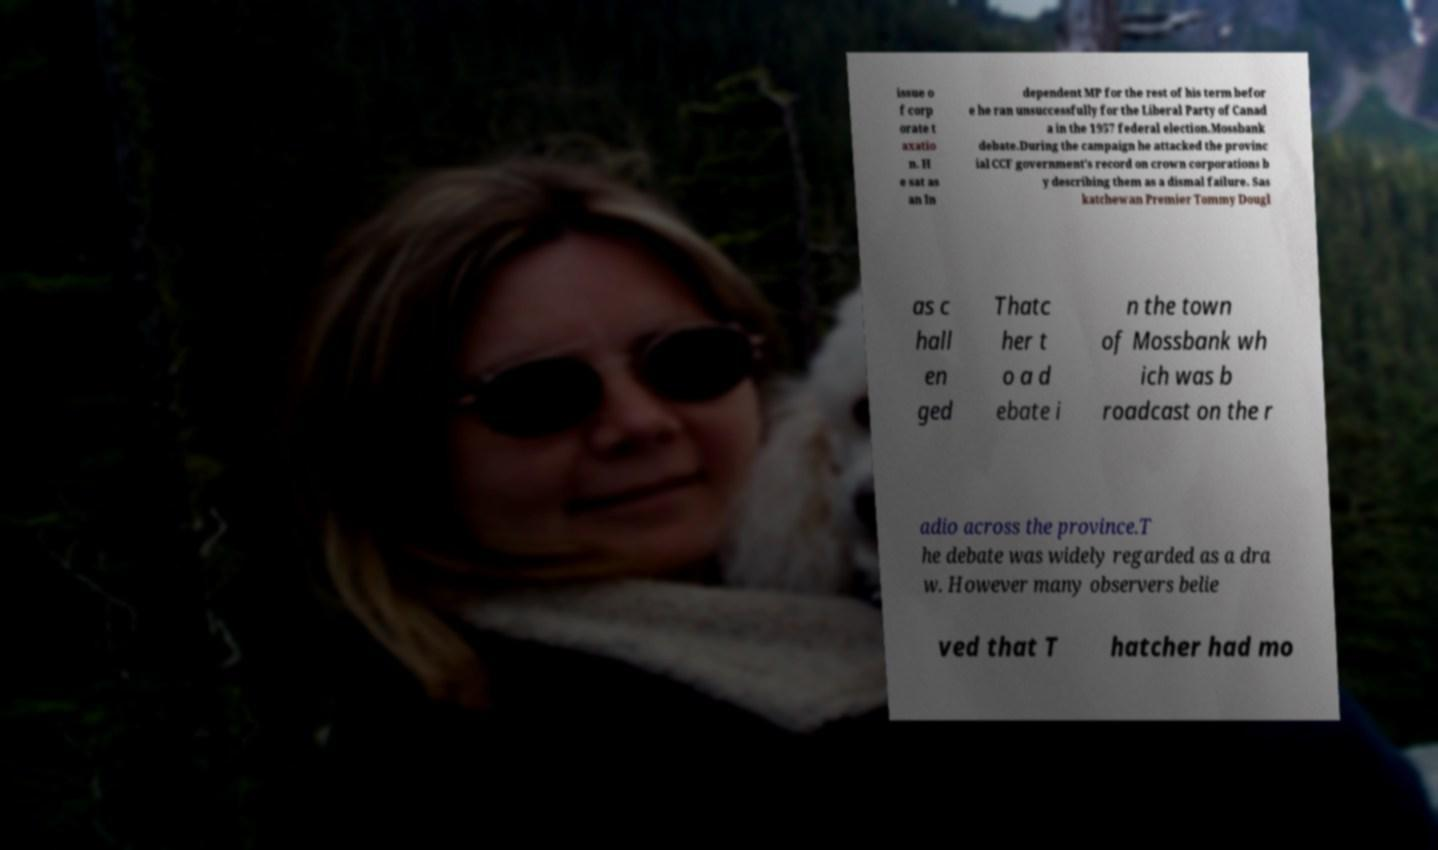I need the written content from this picture converted into text. Can you do that? issue o f corp orate t axatio n. H e sat as an In dependent MP for the rest of his term befor e he ran unsuccessfully for the Liberal Party of Canad a in the 1957 federal election.Mossbank debate.During the campaign he attacked the provinc ial CCF government's record on crown corporations b y describing them as a dismal failure. Sas katchewan Premier Tommy Dougl as c hall en ged Thatc her t o a d ebate i n the town of Mossbank wh ich was b roadcast on the r adio across the province.T he debate was widely regarded as a dra w. However many observers belie ved that T hatcher had mo 